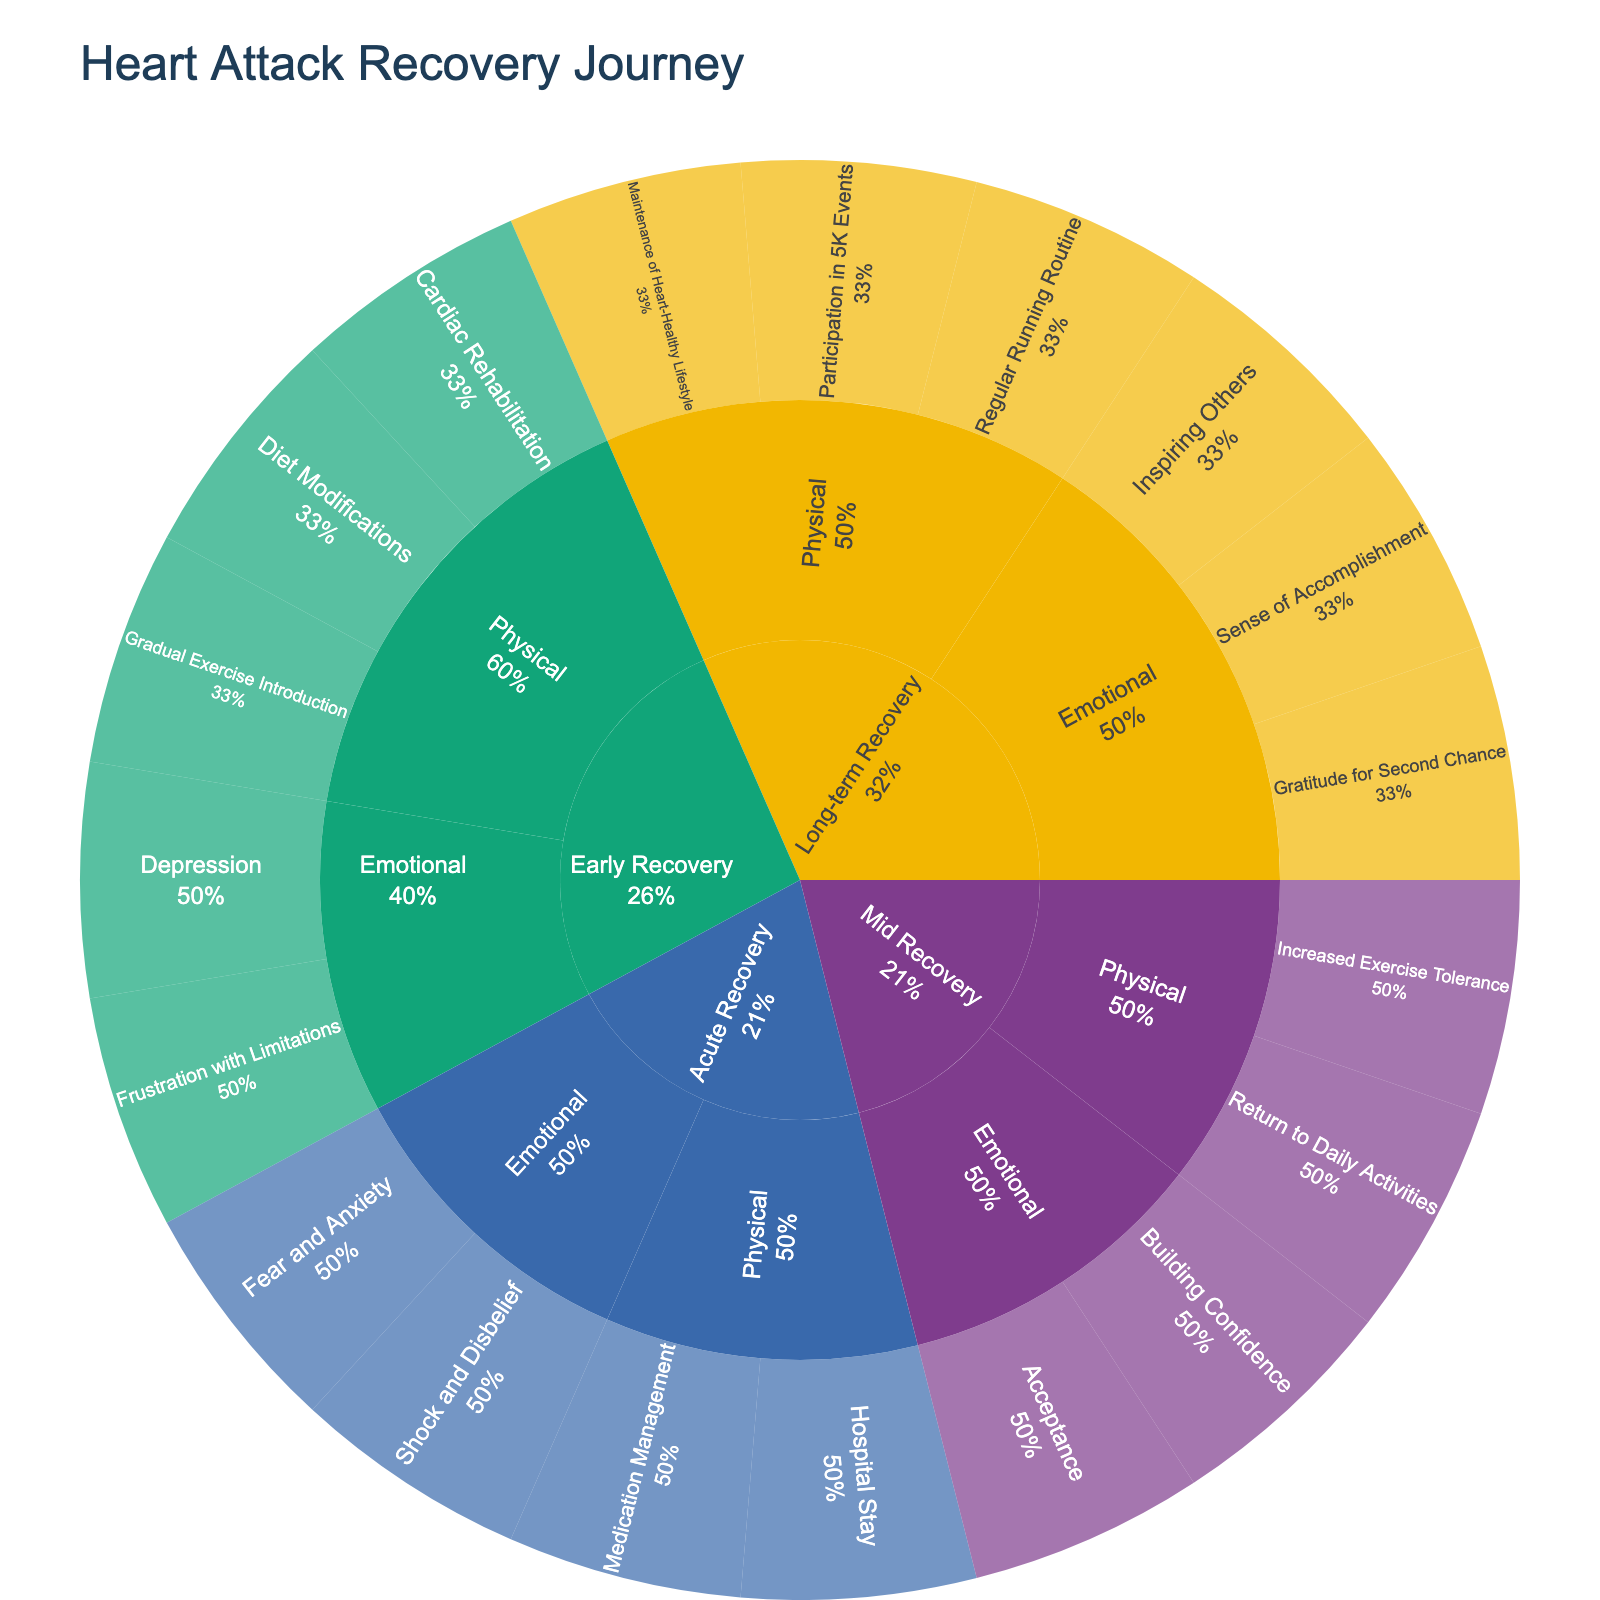What are the main stages of heart attack recovery shown in the sunburst plot? The main stages are the highest level in the hierarchy, typically displayed as the first layer of the sunburst plot surrounding the center.
Answer: Acute Recovery, Early Recovery, Mid Recovery, Long-term Recovery Which stage includes the milestone of "Cardiac Rehabilitation"? To answer this, locate the "Cardiac Rehabilitation" milestone within the hierarchy and trace it back to the stage it belongs to.
Answer: Early Recovery In which stage do emotional milestones such as "Fear and Anxiety" appear? Trace the emotional milestones like "Fear and Anxiety" back to their respective stages within the hierarchy.
Answer: Acute Recovery How many physical milestones are there in the Mid Recovery stage? Count the physical milestones listed under the Mid Recovery stage segment in the hierarchy of the sunburst plot.
Answer: 2 Are there more physical or emotional milestones in the Long-term Recovery stage? Compare the number of physical milestones with emotional milestones within the Long-term Recovery stage by counting each.
Answer: Physical milestones Identify a milestone that appears in the Early Recovery stage but not in any other stage. Find a unique milestone under the Early Recovery stage that is not repeated in other stages.
Answer: Cardiac Rehabilitation Which emotional milestone in the sunburst plot is related to inspiring others? Look for the milestone "Inspiring Others" and identify the type of milestone it is by its placement within the sunburst plot hierarchy.
Answer: Emotional Between the Acute Recovery and Mid Recovery stages, which has more emotional milestones? Count the number of emotional milestones in both the Acute Recovery and Mid Recovery stages and compare the totals.
Answer: Acute Recovery What stage follows right after Acute Recovery in the hierarchy? The hierarchy shown in a sunburst plot typically flows outward, so identify the next layer following Acute Recovery.
Answer: Early Recovery How many milestones are associated with maintaining a heart-healthy lifestyle, and in which stage do they occur? Locate the "Maintenance of Heart-Healthy Lifestyle" milestone in the hierarchy and count the corresponding number of milestones.
Answer: 1 milestone in Long-term Recovery 